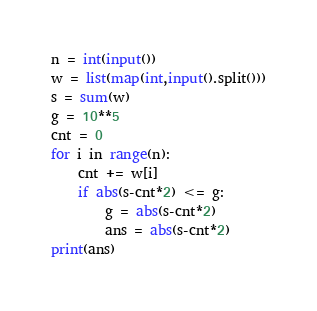Convert code to text. <code><loc_0><loc_0><loc_500><loc_500><_Python_>n = int(input())
w = list(map(int,input().split()))
s = sum(w)
g = 10**5
cnt = 0
for i in range(n):
    cnt += w[i]
    if abs(s-cnt*2) <= g:
        g = abs(s-cnt*2)
        ans = abs(s-cnt*2)
print(ans)</code> 